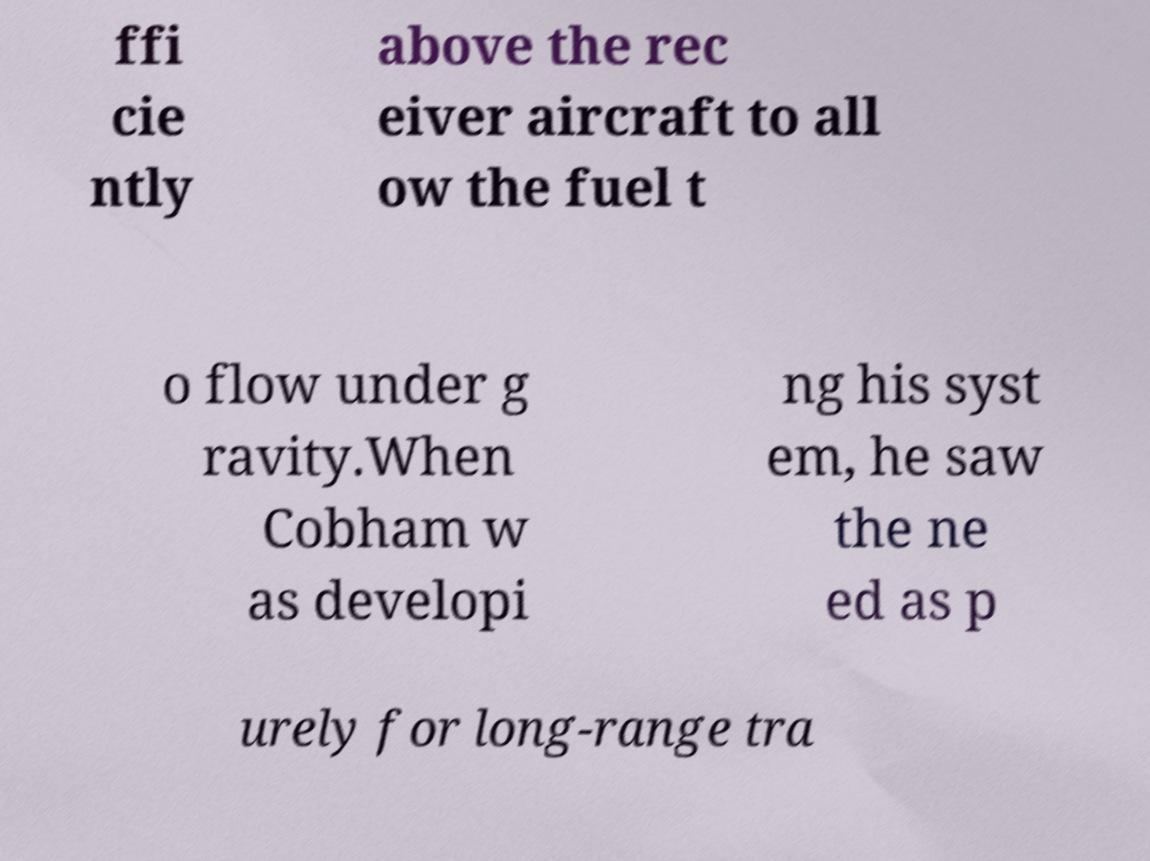Could you extract and type out the text from this image? ffi cie ntly above the rec eiver aircraft to all ow the fuel t o flow under g ravity.When Cobham w as developi ng his syst em, he saw the ne ed as p urely for long-range tra 